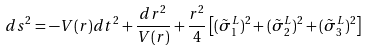<formula> <loc_0><loc_0><loc_500><loc_500>d s ^ { 2 } = - V ( r ) d t ^ { 2 } + \frac { d r ^ { 2 } } { V ( r ) } + \frac { r ^ { 2 } } { 4 } \left [ ( \tilde { \sigma } _ { 1 } ^ { L } ) ^ { 2 } + ( \tilde { \sigma } _ { 2 } ^ { L } ) ^ { 2 } + ( \tilde { \sigma } _ { 3 } ^ { L } ) ^ { 2 } \right ]</formula> 